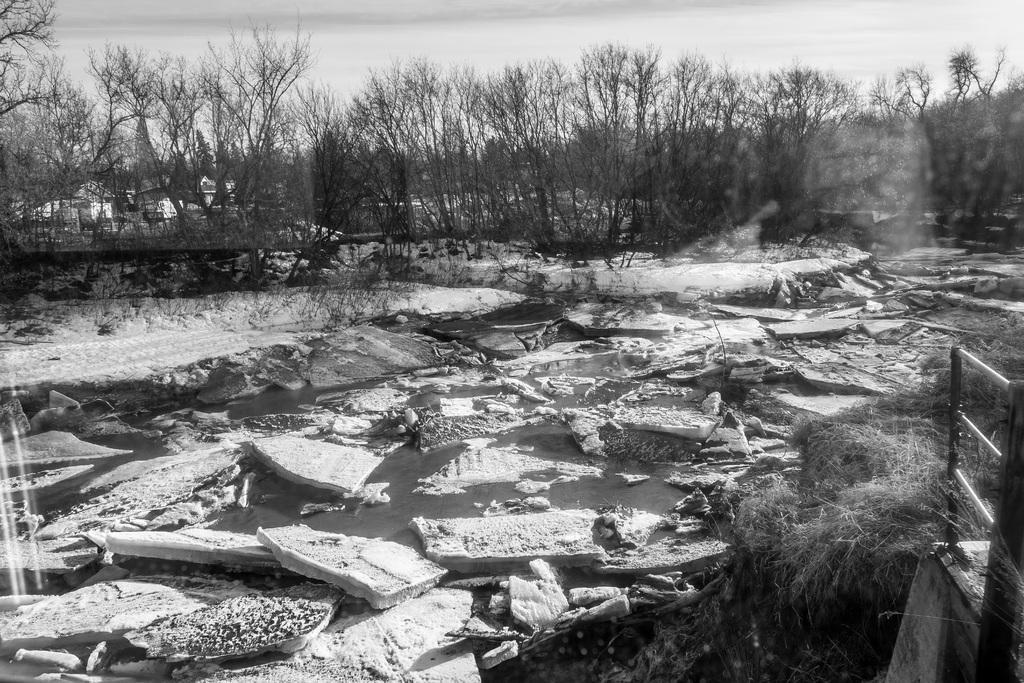Could you give a brief overview of what you see in this image? In this image we can see the broken wooden blocks floating on the water. Here we can see the grass and a metal fence on the right side. In the background, we can see the trees. 